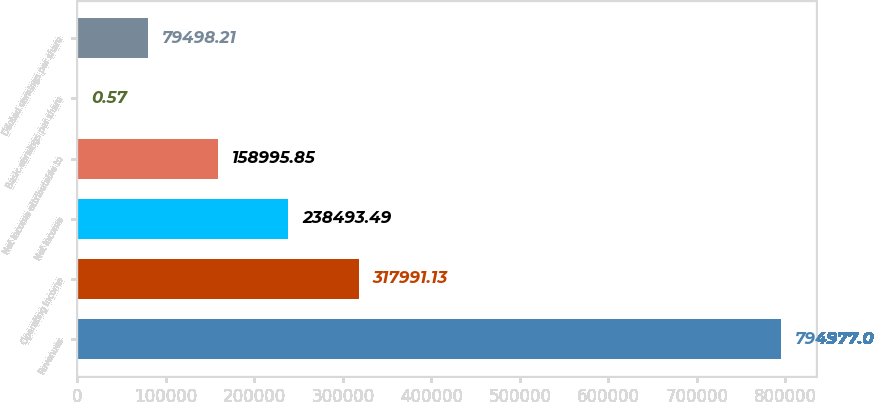Convert chart to OTSL. <chart><loc_0><loc_0><loc_500><loc_500><bar_chart><fcel>Revenues<fcel>Operating income<fcel>Net income<fcel>Net income attributable to<fcel>Basic earnings per share<fcel>Diluted earnings per share<nl><fcel>794977<fcel>317991<fcel>238493<fcel>158996<fcel>0.57<fcel>79498.2<nl></chart> 